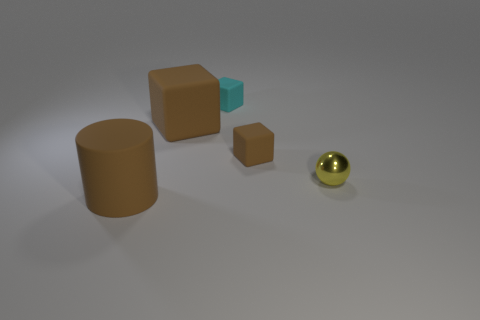Subtract all brown matte cubes. How many cubes are left? 1 Subtract all yellow cylinders. How many brown blocks are left? 2 Subtract 2 cubes. How many cubes are left? 1 Add 3 small brown objects. How many objects exist? 8 Subtract all cubes. How many objects are left? 2 Add 1 big red cubes. How many big red cubes exist? 1 Subtract 0 purple spheres. How many objects are left? 5 Subtract all green cubes. Subtract all cyan cylinders. How many cubes are left? 3 Subtract all brown matte things. Subtract all small cyan rubber objects. How many objects are left? 1 Add 2 tiny yellow spheres. How many tiny yellow spheres are left? 3 